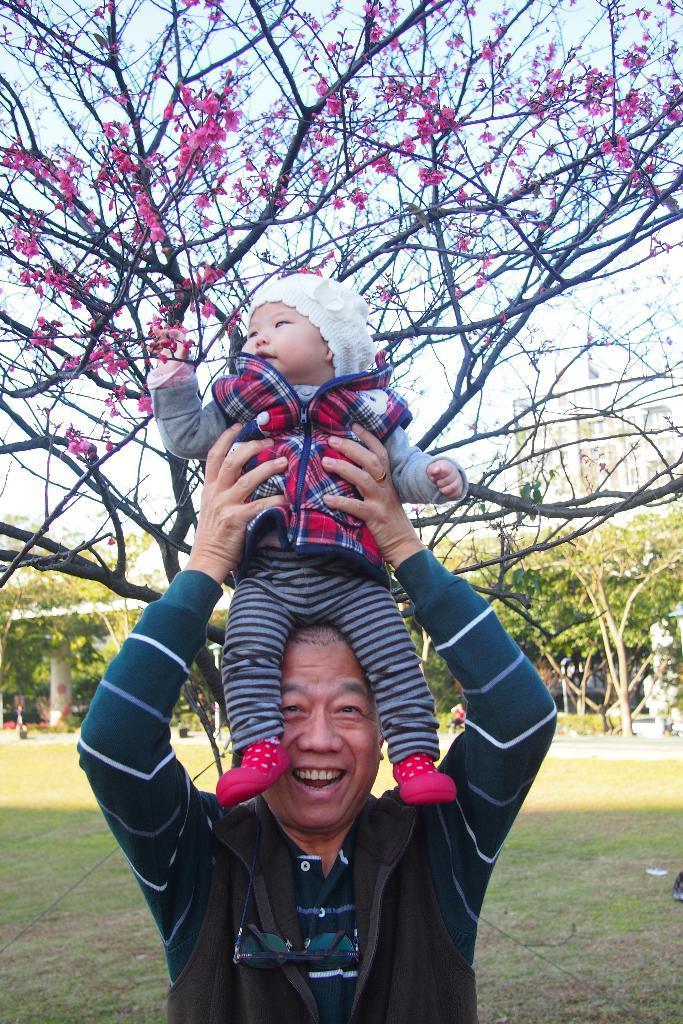Can you describe this image briefly? In this image we can see a person holding a kid, there are some trees and grass on the ground, also we can see a building, in the background, we can see the sky. 